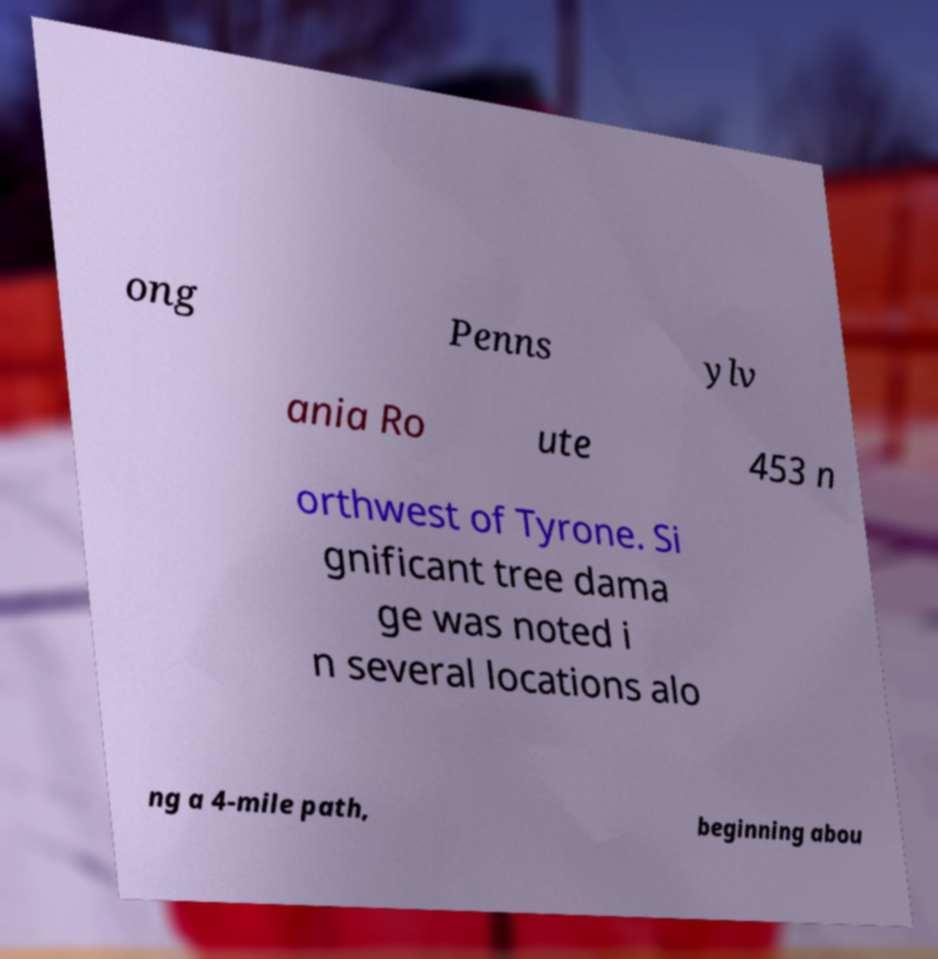Can you read and provide the text displayed in the image?This photo seems to have some interesting text. Can you extract and type it out for me? ong Penns ylv ania Ro ute 453 n orthwest of Tyrone. Si gnificant tree dama ge was noted i n several locations alo ng a 4-mile path, beginning abou 